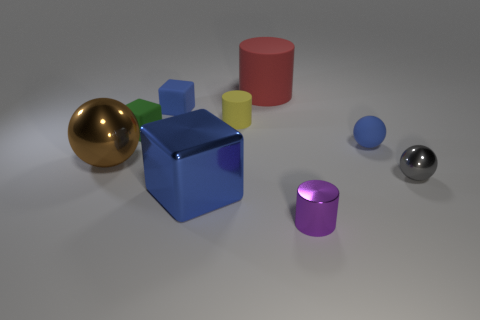There is a blue object that is both right of the small blue rubber block and left of the purple metal thing; what shape is it?
Give a very brief answer. Cube. What is the color of the other rubber thing that is the same shape as the large rubber object?
Provide a succinct answer. Yellow. What number of things are matte objects to the left of the blue matte sphere or large objects that are to the right of the green cube?
Offer a terse response. 5. There is a small gray thing; what shape is it?
Ensure brevity in your answer.  Sphere. What is the shape of the small object that is the same color as the rubber sphere?
Offer a terse response. Cube. How many cubes have the same material as the small purple object?
Provide a short and direct response. 1. The large ball is what color?
Your answer should be compact. Brown. The matte cylinder that is the same size as the blue metallic block is what color?
Your response must be concise. Red. Is there a big metal thing that has the same color as the small metal ball?
Ensure brevity in your answer.  No. There is a large object that is behind the brown sphere; is its shape the same as the tiny blue object to the left of the red thing?
Offer a very short reply. No. 